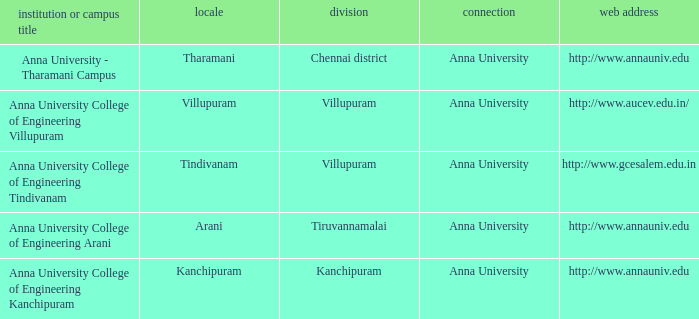What District has a Location of villupuram? Villupuram. 